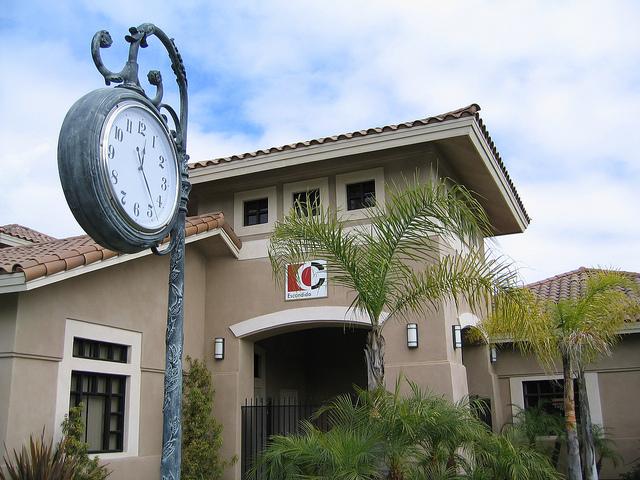Is this house located in Manhattan?
Concise answer only. No. What is above the archway?
Keep it brief. Sign. What time is it?
Be succinct. 12:25. 